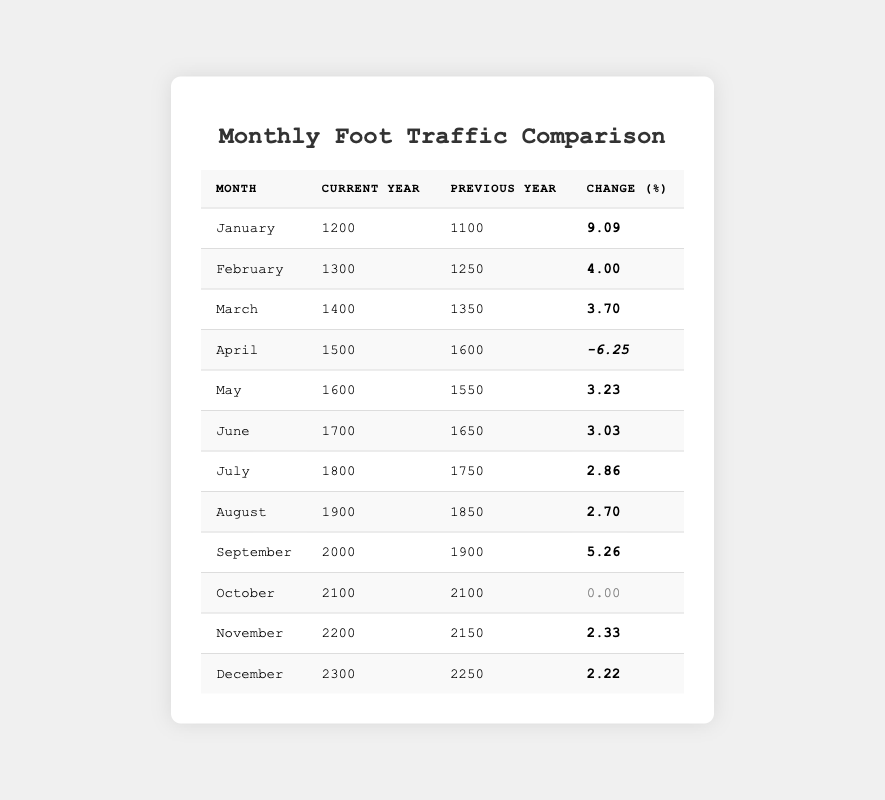What was the foot traffic in January for the current year? Referring to the table, the entry for January in the current year shows a foot traffic value of 1200.
Answer: 1200 What was the percentage change in foot traffic for March? In March, the change percentage is listed as 3.70% in the table.
Answer: 3.70% Did foot traffic decrease in April compared to the previous year? The table shows that the foot traffic in April decreased from 1600 to 1500, indicating a negative change of -6.25%. Therefore, yes, it decreased.
Answer: Yes Which month had the highest current year foot traffic? Scanning through the current year values, December has the highest foot traffic at 2300, which makes it the month with the highest foot traffic.
Answer: December What is the total foot traffic for the current year from January to June? To calculate this, we add the current year foot traffic from January to June: 1200 + 1300 + 1400 + 1500 + 1600 + 1700 = 10200.
Answer: 10200 What was the average change percentage for the months from May to November? The change percentages for these months are 3.23, 3.03, 2.86, 2.70, 5.26, 0.00, 2.33. Adding these values gives 19.41, and dividing by the number of months (7) results in approximately 2.77%.
Answer: 2.77% What month had no change in foot traffic from the previous year? According to the table, October is highlighted as having a change of 0.00%, indicating no change in foot traffic from the previous year.
Answer: October How much more foot traffic was there in December compared to January? In December, the current year foot traffic was 2300 and in January it was 1200. Subtracting these values gives 2300 - 1200 = 1100, which is the additional foot traffic in December.
Answer: 1100 How did the foot traffic in September compare to that in August? The table shows that foot traffic in September (2000) was higher than in August (1900), indicating an increase of 100 foot traffic.
Answer: Higher Was the foot traffic improvement consistent throughout the year? By analyzing the monthly changes, it can be seen that the change fluctuated with both increases and a decrease (in April). Therefore, it was not consistent throughout the year.
Answer: No What is the difference in foot traffic for the months with the lowest and highest changes? The lowest change was in April (-6.25) and the highest change is in January (9.09). The difference in their foot traffic values, after evaluating the change, would be January's 1200 and April's 1500, resulting in a difference of 300.
Answer: 300 